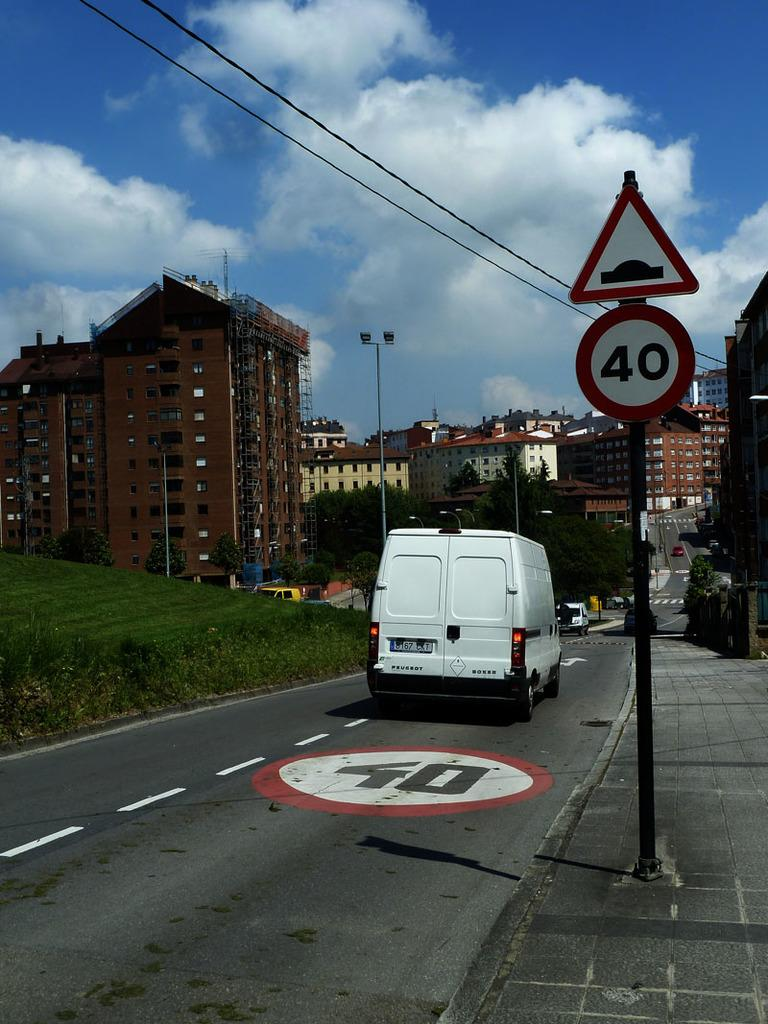<image>
Give a short and clear explanation of the subsequent image. A white van is driving down a road with the number 40 printed on the right hand lane. 